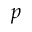<formula> <loc_0><loc_0><loc_500><loc_500>p</formula> 